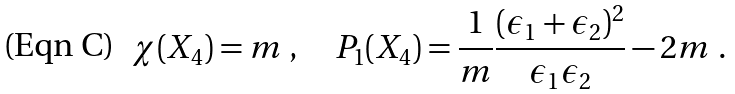<formula> <loc_0><loc_0><loc_500><loc_500>\chi ( X _ { 4 } ) = m \ , \quad P _ { 1 } ( X _ { 4 } ) = \frac { 1 } { m } \frac { ( \epsilon _ { 1 } + \epsilon _ { 2 } ) ^ { 2 } } { \epsilon _ { 1 } \epsilon _ { 2 } } - 2 m \ .</formula> 